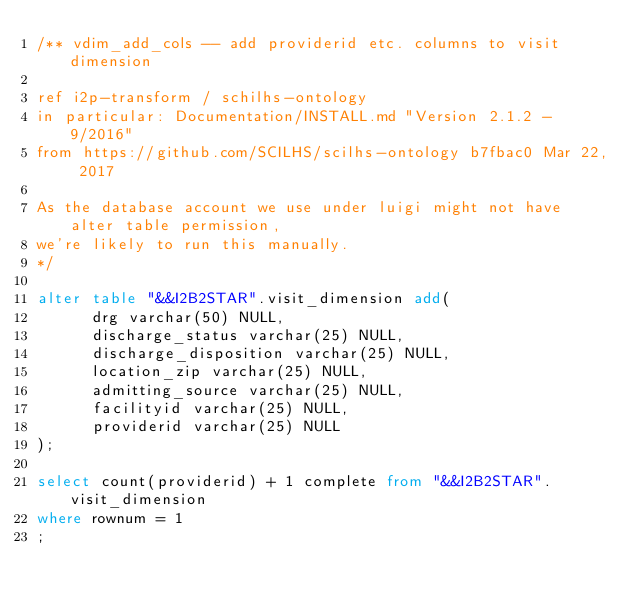<code> <loc_0><loc_0><loc_500><loc_500><_SQL_>/** vdim_add_cols -- add providerid etc. columns to visit dimension

ref i2p-transform / schilhs-ontology
in particular: Documentation/INSTALL.md "Version 2.1.2 - 9/2016"
from https://github.com/SCILHS/scilhs-ontology b7fbac0 Mar 22, 2017

As the database account we use under luigi might not have alter table permission,
we're likely to run this manually.
*/

alter table "&&I2B2STAR".visit_dimension add(
      drg varchar(50) NULL,
      discharge_status varchar(25) NULL,
      discharge_disposition varchar(25) NULL,
      location_zip varchar(25) NULL,
      admitting_source varchar(25) NULL,
      facilityid varchar(25) NULL,
      providerid varchar(25) NULL
);

select count(providerid) + 1 complete from "&&I2B2STAR".visit_dimension
where rownum = 1
;
</code> 